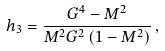<formula> <loc_0><loc_0><loc_500><loc_500>h _ { 3 } = \frac { G ^ { 4 } - M ^ { 2 } } { M ^ { 2 } G ^ { 2 } \left ( 1 - M ^ { 2 } \right ) } \, ,</formula> 